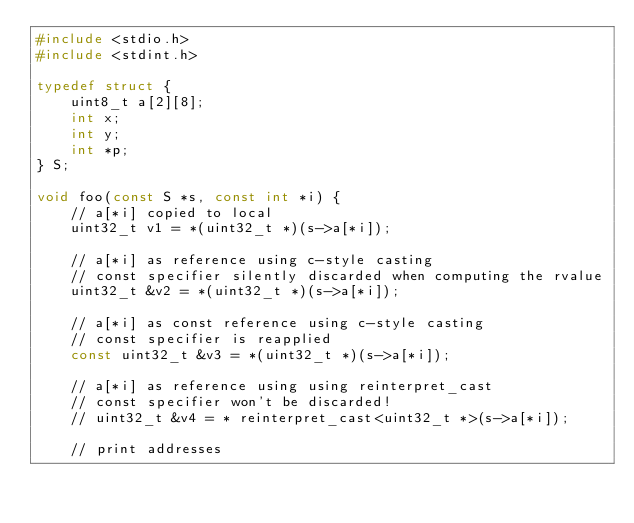Convert code to text. <code><loc_0><loc_0><loc_500><loc_500><_C++_>#include <stdio.h>
#include <stdint.h>

typedef struct {
    uint8_t a[2][8];
    int x;
    int y;
    int *p;
} S;

void foo(const S *s, const int *i) {
    // a[*i] copied to local
    uint32_t v1 = *(uint32_t *)(s->a[*i]);

    // a[*i] as reference using c-style casting
    // const specifier silently discarded when computing the rvalue
    uint32_t &v2 = *(uint32_t *)(s->a[*i]);

    // a[*i] as const reference using c-style casting
    // const specifier is reapplied
    const uint32_t &v3 = *(uint32_t *)(s->a[*i]);

    // a[*i] as reference using using reinterpret_cast
    // const specifier won't be discarded!
    // uint32_t &v4 = * reinterpret_cast<uint32_t *>(s->a[*i]);

    // print addresses</code> 